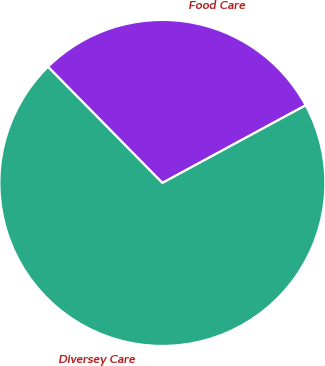<chart> <loc_0><loc_0><loc_500><loc_500><pie_chart><fcel>Food Care<fcel>Diversey Care<nl><fcel>29.48%<fcel>70.52%<nl></chart> 